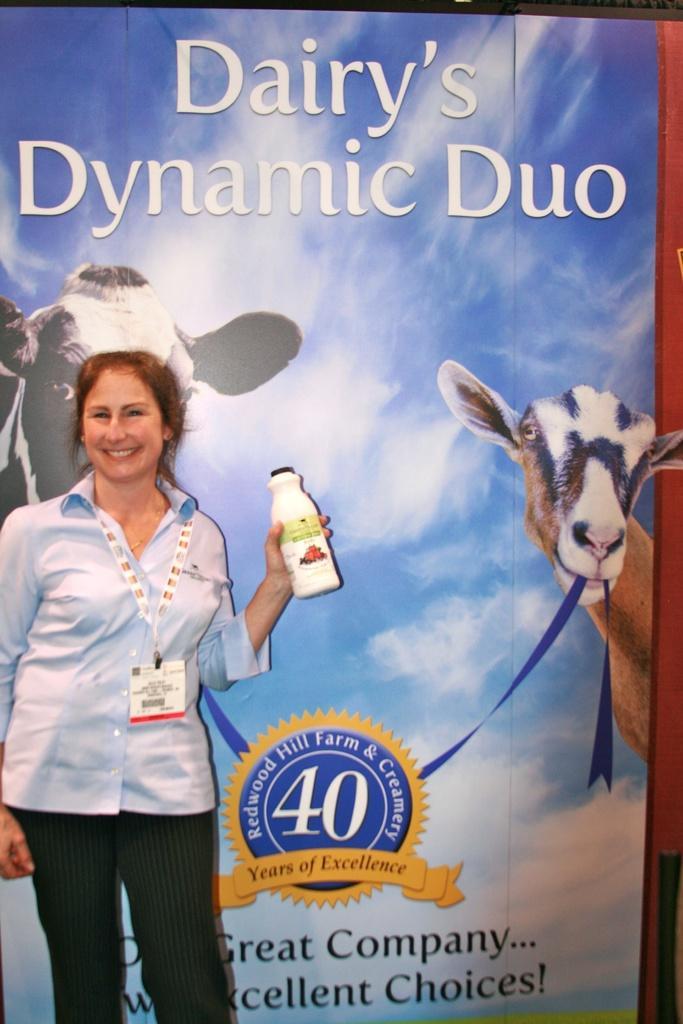How would you summarize this image in a sentence or two? In this image we have a woman who is wearing a blue shirt and black pant and wearing an ID card. The woman is smiling and holding a bottle. 